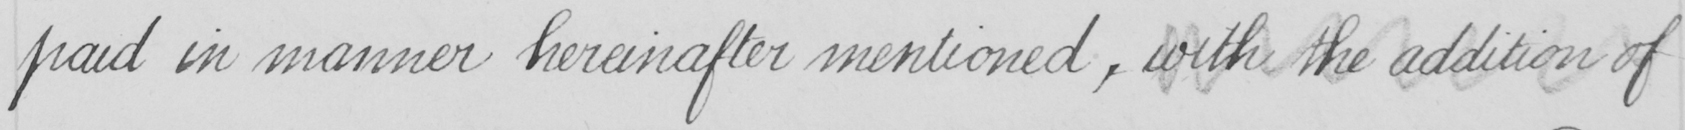Can you read and transcribe this handwriting? paid in manner hereinafter mentioned , with the addition of 